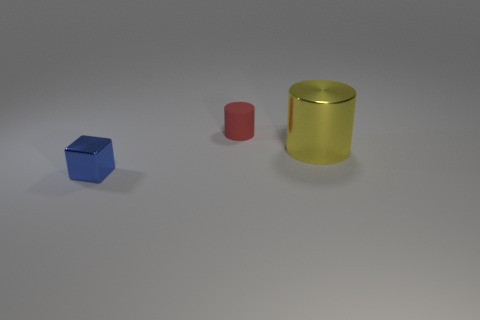There is a small object behind the yellow metal thing; what shape is it?
Offer a very short reply. Cylinder. There is another thing that is the same shape as the big yellow metallic thing; what is its size?
Give a very brief answer. Small. Is the color of the shiny cylinder the same as the tiny cylinder?
Make the answer very short. No. Is there anything else that has the same shape as the yellow metal object?
Provide a short and direct response. Yes. Is there a tiny matte cylinder that is behind the shiny object that is left of the red rubber thing?
Provide a succinct answer. Yes. There is another object that is the same shape as the small red thing; what color is it?
Your answer should be very brief. Yellow. The metal thing that is on the left side of the cylinder behind the metal thing that is to the right of the cube is what color?
Your response must be concise. Blue. Do the tiny block and the tiny cylinder have the same material?
Keep it short and to the point. No. Is the blue metallic thing the same shape as the small matte object?
Keep it short and to the point. No. Are there an equal number of small things that are behind the blue thing and blocks that are on the left side of the large cylinder?
Your answer should be compact. Yes. 